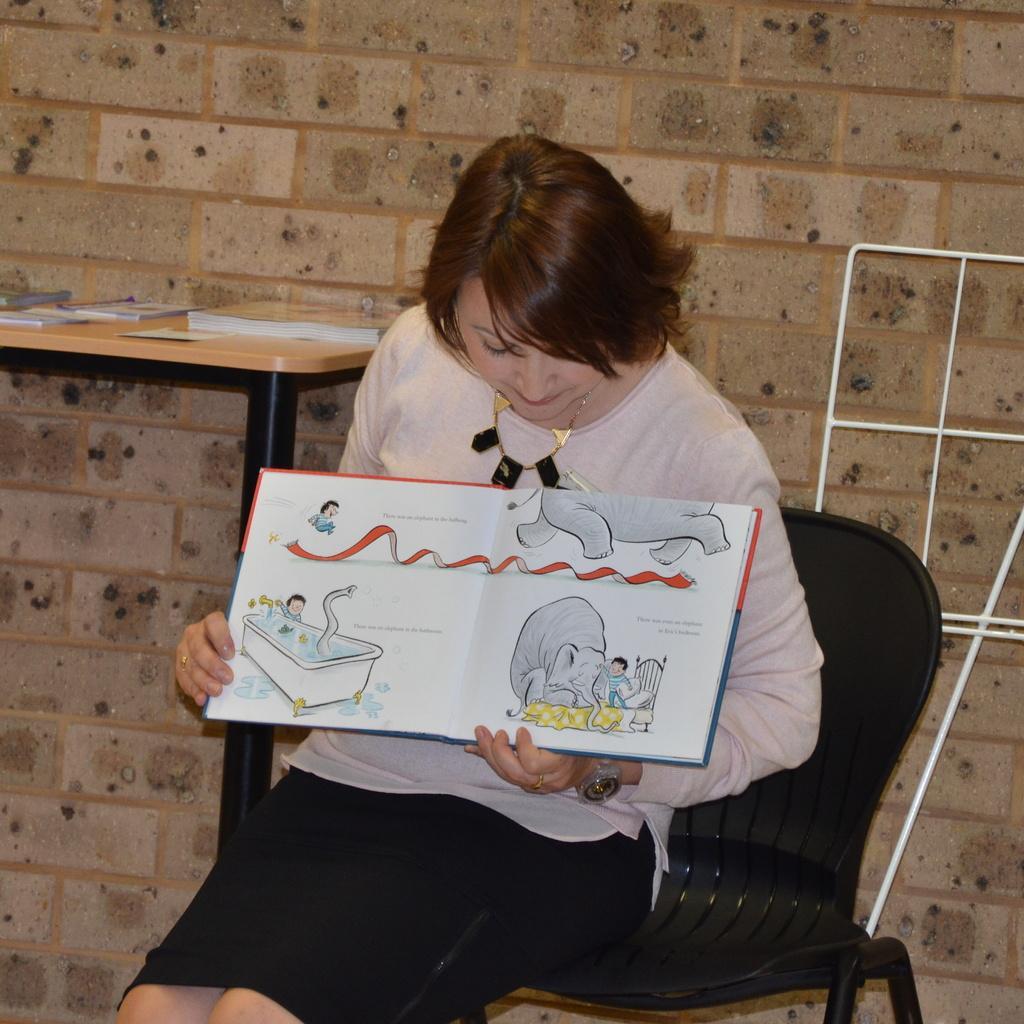Please provide a concise description of this image. She is sitting on a chair. She is holding a book. We can see in background table and wall. 